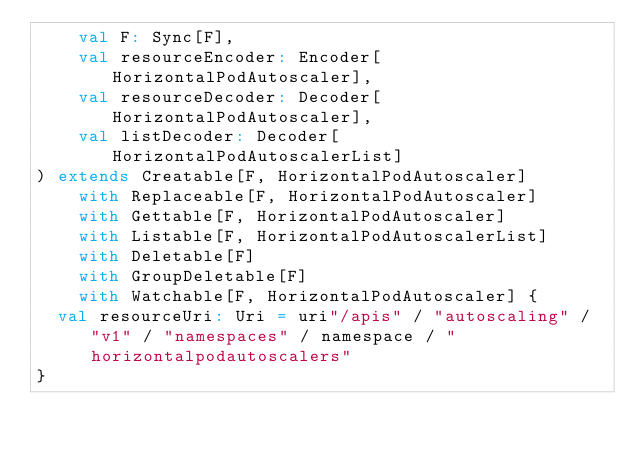Convert code to text. <code><loc_0><loc_0><loc_500><loc_500><_Scala_>    val F: Sync[F],
    val resourceEncoder: Encoder[HorizontalPodAutoscaler],
    val resourceDecoder: Decoder[HorizontalPodAutoscaler],
    val listDecoder: Decoder[HorizontalPodAutoscalerList]
) extends Creatable[F, HorizontalPodAutoscaler]
    with Replaceable[F, HorizontalPodAutoscaler]
    with Gettable[F, HorizontalPodAutoscaler]
    with Listable[F, HorizontalPodAutoscalerList]
    with Deletable[F]
    with GroupDeletable[F]
    with Watchable[F, HorizontalPodAutoscaler] {
  val resourceUri: Uri = uri"/apis" / "autoscaling" / "v1" / "namespaces" / namespace / "horizontalpodautoscalers"
}
</code> 